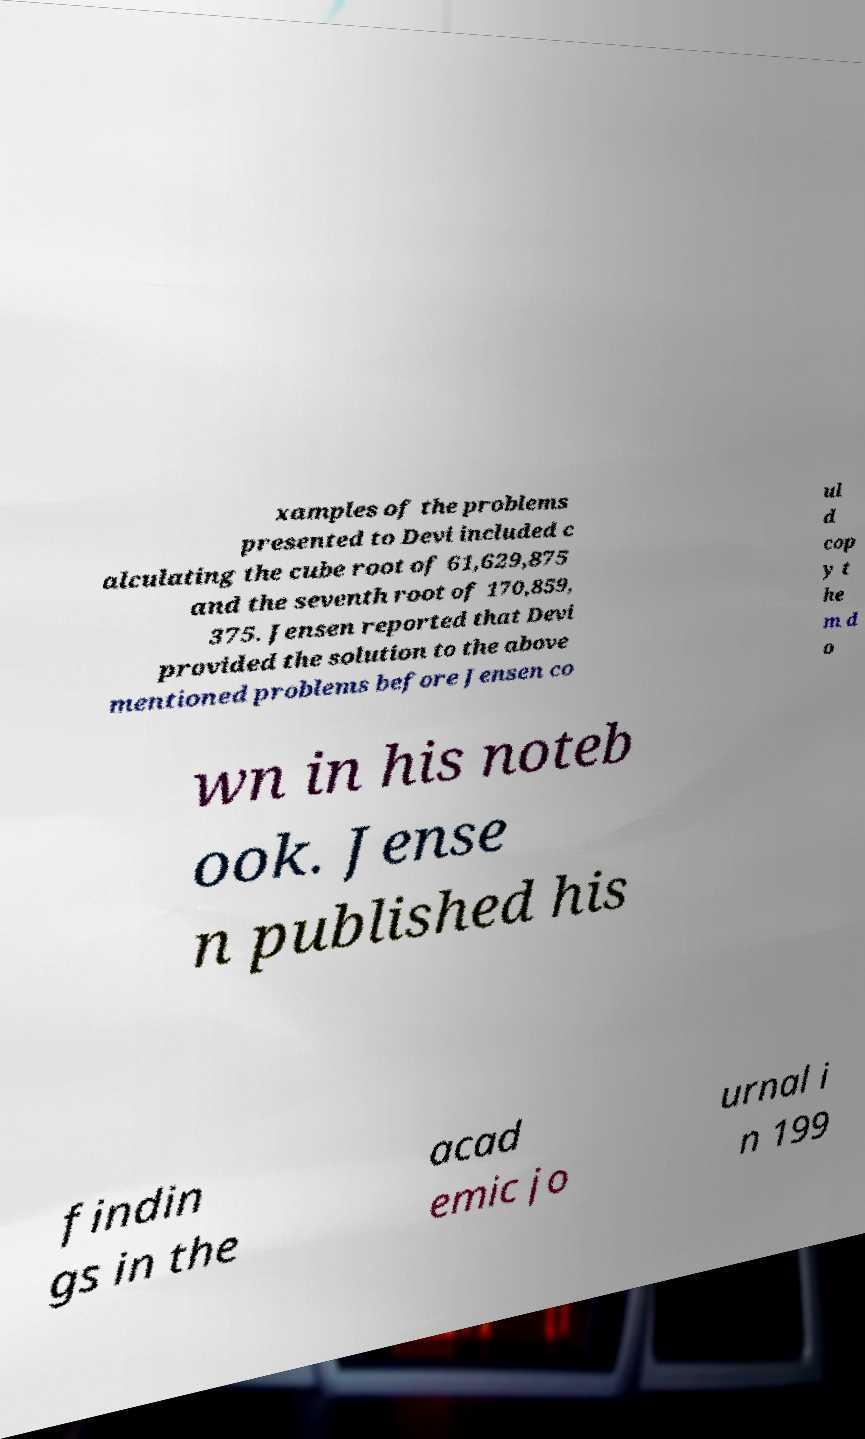There's text embedded in this image that I need extracted. Can you transcribe it verbatim? xamples of the problems presented to Devi included c alculating the cube root of 61,629,875 and the seventh root of 170,859, 375. Jensen reported that Devi provided the solution to the above mentioned problems before Jensen co ul d cop y t he m d o wn in his noteb ook. Jense n published his findin gs in the acad emic jo urnal i n 199 